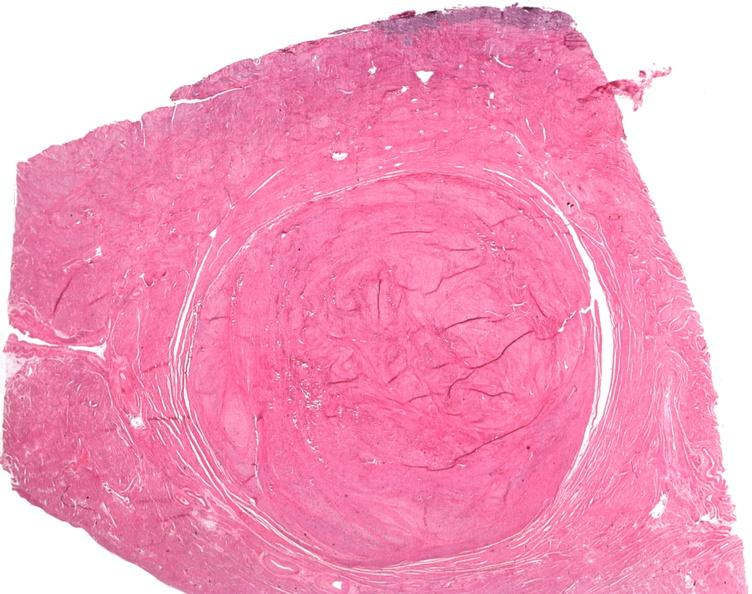does close-up tumor show uterus, leiomyoma?
Answer the question using a single word or phrase. No 